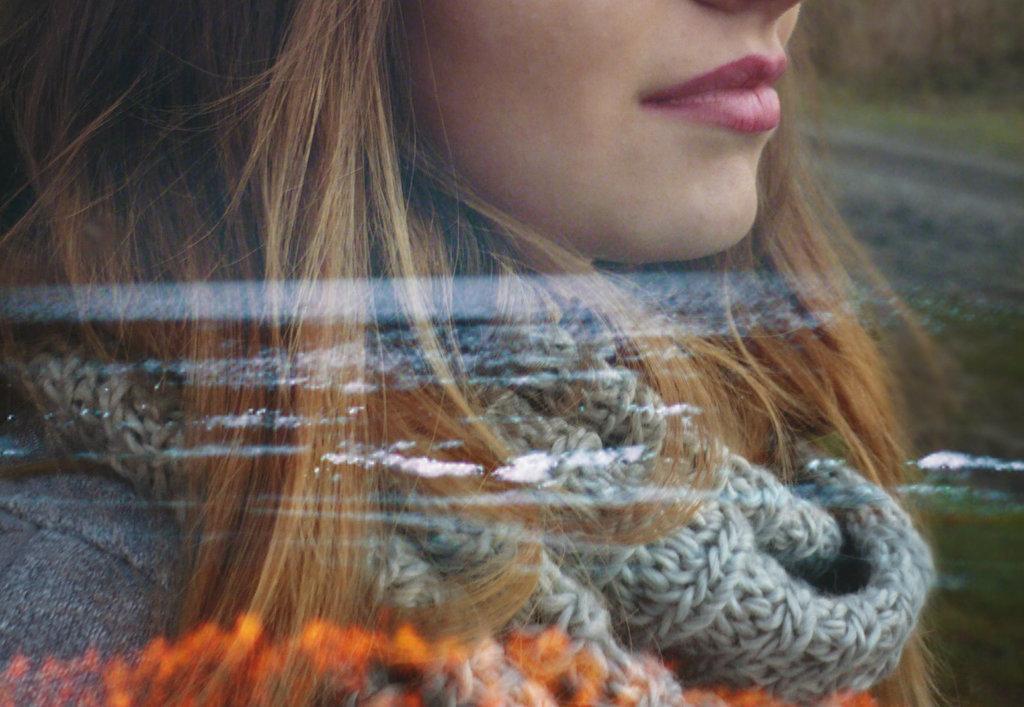Could you give a brief overview of what you see in this image? In this picture we can see a transparent material. Behind the transparent material, there is a woman with the scarf. 